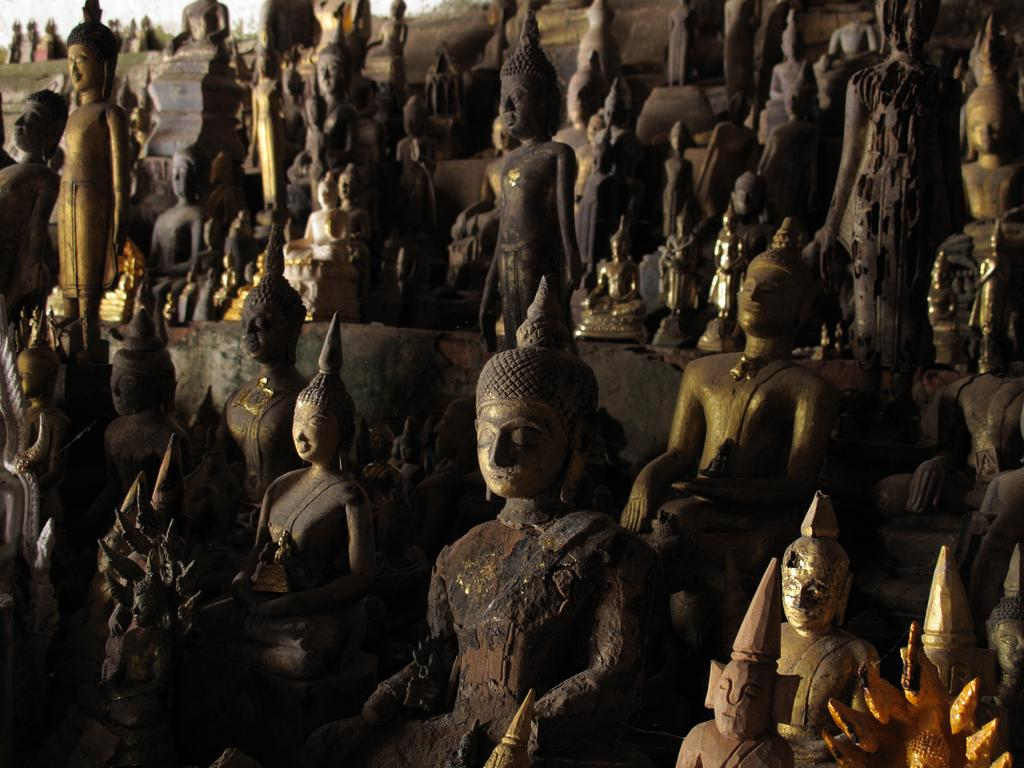What type of objects can be seen in the image? There are statues in the image. Can you describe the statues in more detail? Unfortunately, the provided facts do not offer any additional details about the statues. Are the statues the only objects present in the image? The provided facts only mention the presence of statues, so we cannot confirm or deny the presence of other objects. What type of root system can be seen growing from the statues in the image? There is no mention of roots or any plant life in the provided facts, so we cannot answer this question. 